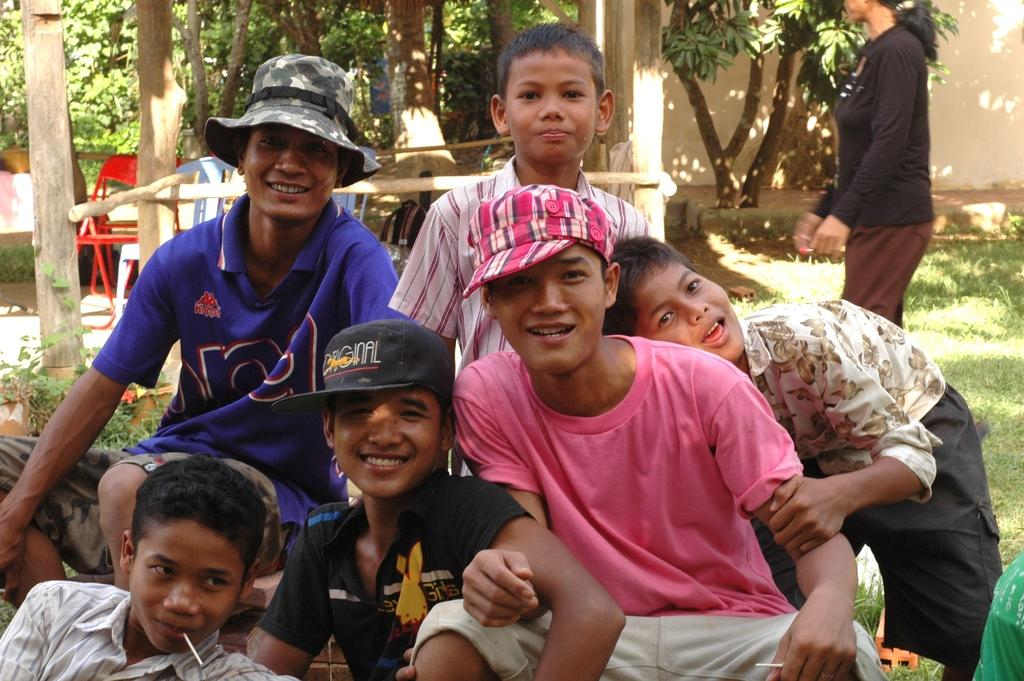How many people are in the group in the image? There is a group of people in the image, but the exact number is not specified. What are some people in the group wearing? Some people in the group are wearing caps. What can be seen in the background of the image? In the background of the image, there are chairs, trees, grass, a wall, and some unspecified objects. What type of surface is visible in the background of the image? Grass is present in the background of the image. How many girls are writing in the image? There is no girl present in the image, nor is there any indication that anyone is writing. What type of giants can be seen in the image? There are no giants present in the image. 